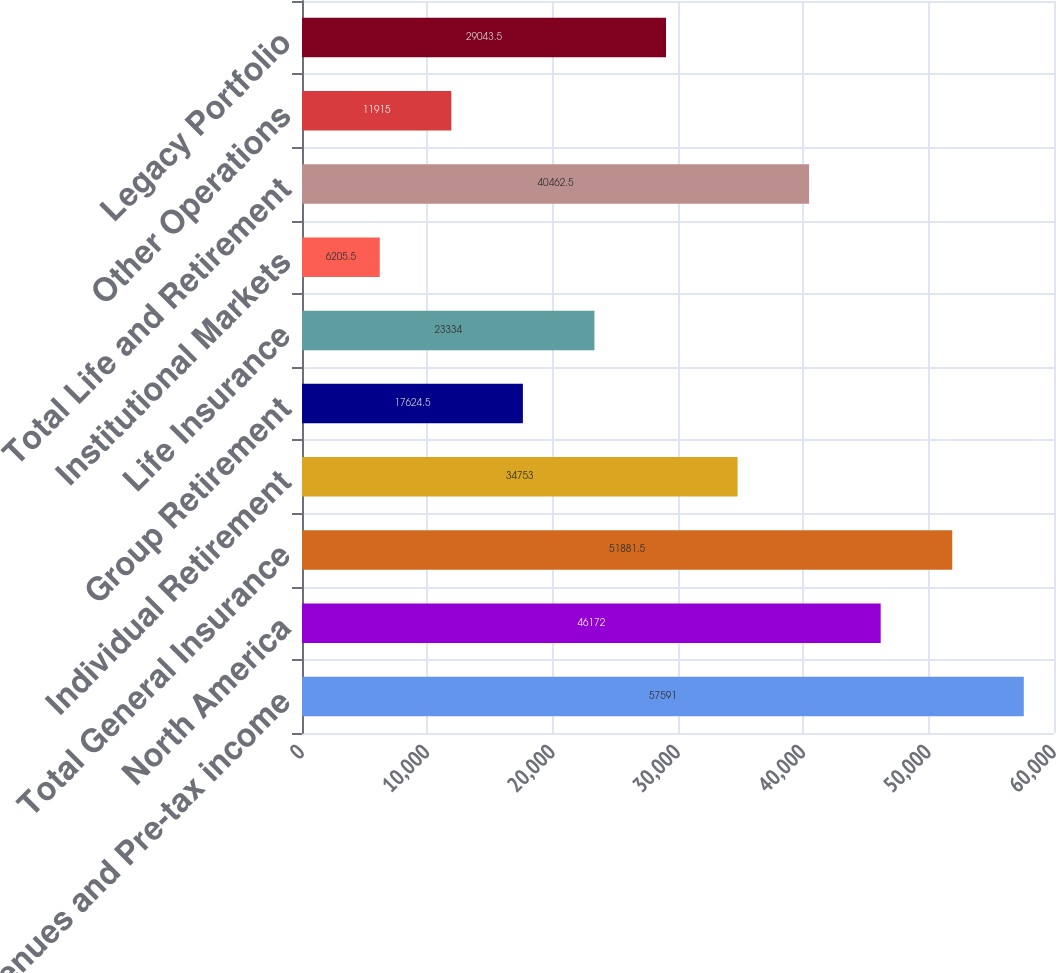Convert chart. <chart><loc_0><loc_0><loc_500><loc_500><bar_chart><fcel>Revenues and Pre-tax income<fcel>North America<fcel>Total General Insurance<fcel>Individual Retirement<fcel>Group Retirement<fcel>Life Insurance<fcel>Institutional Markets<fcel>Total Life and Retirement<fcel>Other Operations<fcel>Legacy Portfolio<nl><fcel>57591<fcel>46172<fcel>51881.5<fcel>34753<fcel>17624.5<fcel>23334<fcel>6205.5<fcel>40462.5<fcel>11915<fcel>29043.5<nl></chart> 